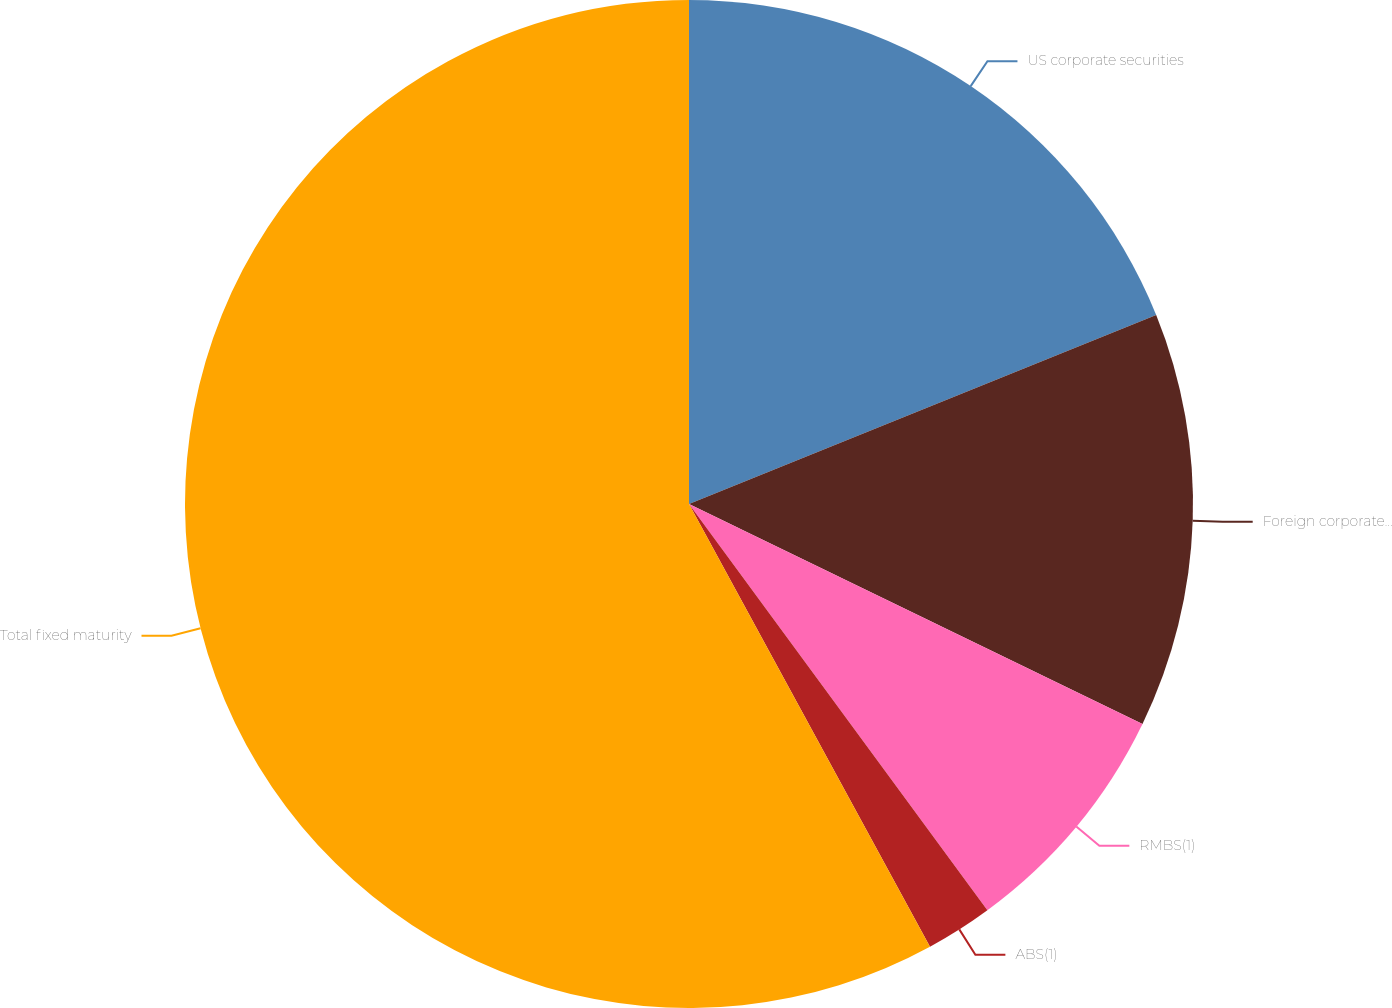Convert chart. <chart><loc_0><loc_0><loc_500><loc_500><pie_chart><fcel>US corporate securities<fcel>Foreign corporate securities<fcel>RMBS(1)<fcel>ABS(1)<fcel>Total fixed maturity<nl><fcel>18.88%<fcel>13.31%<fcel>7.73%<fcel>2.15%<fcel>57.94%<nl></chart> 